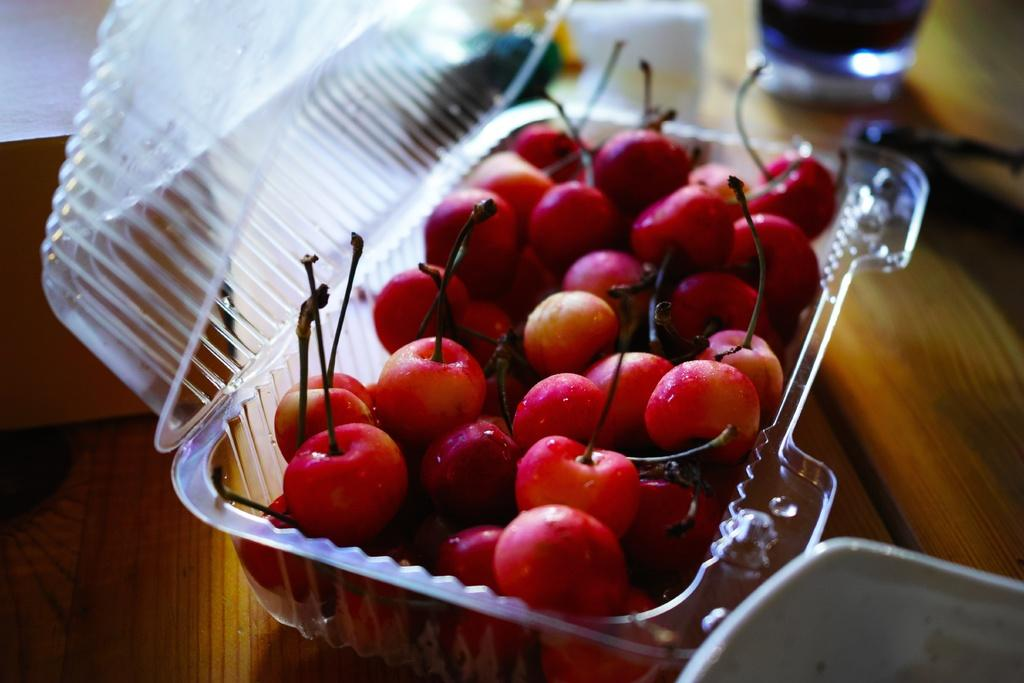What type of furniture is present in the image? There is a table in the image. What is on top of the table? There is a bowl, a plastic box containing cherries, a glass containing liquid, and a pastry box on the table. What is in the bowl? The facts do not specify what is in the bowl. What type of food is in the plastic box? The plastic box contains cherries. What type of berry is the grandfather eating at the party in the image? There is no grandfather or party present in the image, and no berries are mentioned. 